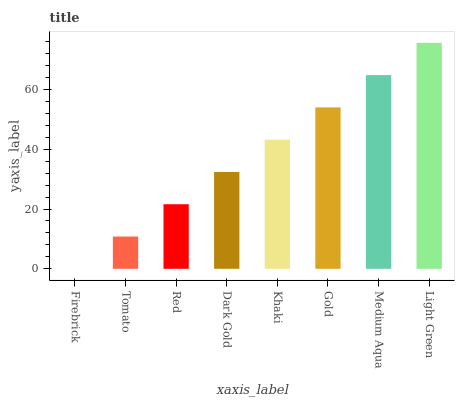Is Firebrick the minimum?
Answer yes or no. Yes. Is Light Green the maximum?
Answer yes or no. Yes. Is Tomato the minimum?
Answer yes or no. No. Is Tomato the maximum?
Answer yes or no. No. Is Tomato greater than Firebrick?
Answer yes or no. Yes. Is Firebrick less than Tomato?
Answer yes or no. Yes. Is Firebrick greater than Tomato?
Answer yes or no. No. Is Tomato less than Firebrick?
Answer yes or no. No. Is Khaki the high median?
Answer yes or no. Yes. Is Dark Gold the low median?
Answer yes or no. Yes. Is Red the high median?
Answer yes or no. No. Is Red the low median?
Answer yes or no. No. 